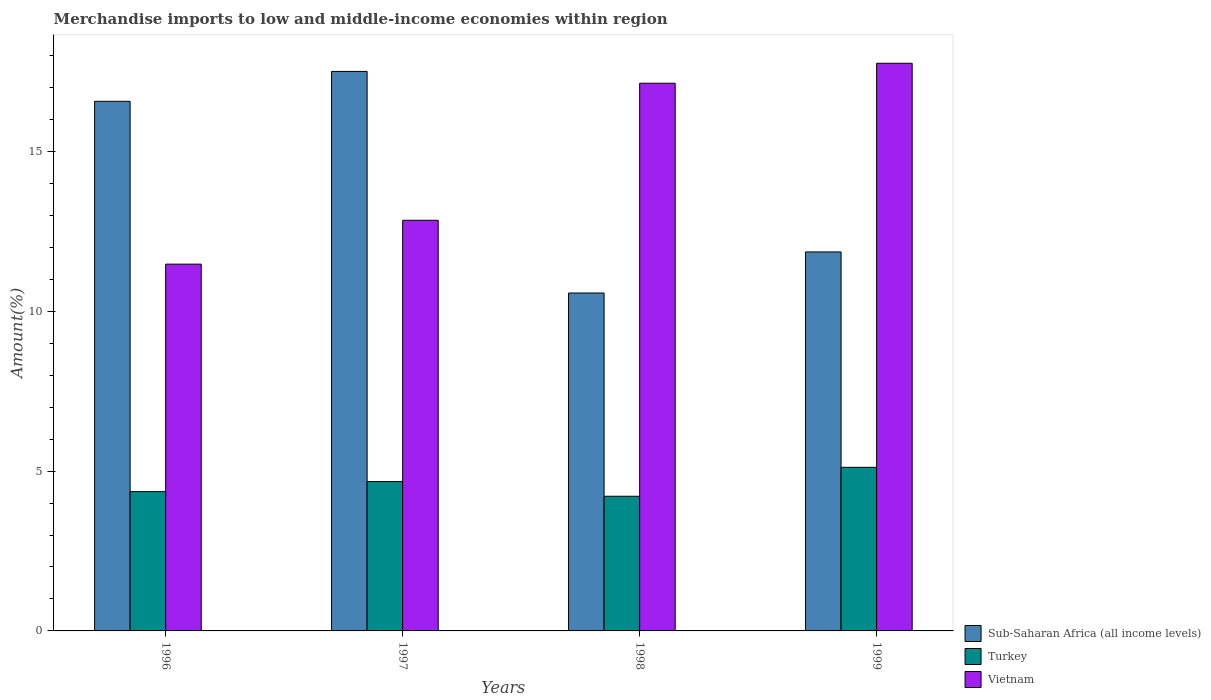How many groups of bars are there?
Keep it short and to the point. 4. How many bars are there on the 2nd tick from the left?
Provide a short and direct response. 3. How many bars are there on the 3rd tick from the right?
Your answer should be compact. 3. In how many cases, is the number of bars for a given year not equal to the number of legend labels?
Keep it short and to the point. 0. What is the percentage of amount earned from merchandise imports in Sub-Saharan Africa (all income levels) in 1999?
Your answer should be very brief. 11.86. Across all years, what is the maximum percentage of amount earned from merchandise imports in Turkey?
Give a very brief answer. 5.12. Across all years, what is the minimum percentage of amount earned from merchandise imports in Sub-Saharan Africa (all income levels)?
Ensure brevity in your answer.  10.57. In which year was the percentage of amount earned from merchandise imports in Sub-Saharan Africa (all income levels) maximum?
Ensure brevity in your answer.  1997. What is the total percentage of amount earned from merchandise imports in Vietnam in the graph?
Give a very brief answer. 59.22. What is the difference between the percentage of amount earned from merchandise imports in Sub-Saharan Africa (all income levels) in 1997 and that in 1999?
Keep it short and to the point. 5.65. What is the difference between the percentage of amount earned from merchandise imports in Turkey in 1998 and the percentage of amount earned from merchandise imports in Sub-Saharan Africa (all income levels) in 1997?
Give a very brief answer. -13.29. What is the average percentage of amount earned from merchandise imports in Turkey per year?
Provide a short and direct response. 4.59. In the year 1996, what is the difference between the percentage of amount earned from merchandise imports in Sub-Saharan Africa (all income levels) and percentage of amount earned from merchandise imports in Turkey?
Keep it short and to the point. 12.21. What is the ratio of the percentage of amount earned from merchandise imports in Turkey in 1998 to that in 1999?
Provide a succinct answer. 0.82. Is the difference between the percentage of amount earned from merchandise imports in Sub-Saharan Africa (all income levels) in 1996 and 1998 greater than the difference between the percentage of amount earned from merchandise imports in Turkey in 1996 and 1998?
Ensure brevity in your answer.  Yes. What is the difference between the highest and the second highest percentage of amount earned from merchandise imports in Sub-Saharan Africa (all income levels)?
Make the answer very short. 0.94. What is the difference between the highest and the lowest percentage of amount earned from merchandise imports in Turkey?
Provide a short and direct response. 0.91. In how many years, is the percentage of amount earned from merchandise imports in Vietnam greater than the average percentage of amount earned from merchandise imports in Vietnam taken over all years?
Offer a terse response. 2. Is the sum of the percentage of amount earned from merchandise imports in Sub-Saharan Africa (all income levels) in 1996 and 1998 greater than the maximum percentage of amount earned from merchandise imports in Vietnam across all years?
Offer a very short reply. Yes. What does the 2nd bar from the left in 1998 represents?
Provide a succinct answer. Turkey. What does the 3rd bar from the right in 1996 represents?
Your response must be concise. Sub-Saharan Africa (all income levels). Are all the bars in the graph horizontal?
Provide a succinct answer. No. How many years are there in the graph?
Offer a terse response. 4. What is the difference between two consecutive major ticks on the Y-axis?
Make the answer very short. 5. Are the values on the major ticks of Y-axis written in scientific E-notation?
Give a very brief answer. No. Does the graph contain grids?
Provide a short and direct response. No. What is the title of the graph?
Your answer should be very brief. Merchandise imports to low and middle-income economies within region. Does "Luxembourg" appear as one of the legend labels in the graph?
Your answer should be very brief. No. What is the label or title of the X-axis?
Offer a terse response. Years. What is the label or title of the Y-axis?
Your answer should be very brief. Amount(%). What is the Amount(%) of Sub-Saharan Africa (all income levels) in 1996?
Offer a very short reply. 16.57. What is the Amount(%) of Turkey in 1996?
Your answer should be very brief. 4.36. What is the Amount(%) of Vietnam in 1996?
Offer a terse response. 11.48. What is the Amount(%) of Sub-Saharan Africa (all income levels) in 1997?
Give a very brief answer. 17.51. What is the Amount(%) of Turkey in 1997?
Keep it short and to the point. 4.67. What is the Amount(%) in Vietnam in 1997?
Ensure brevity in your answer.  12.85. What is the Amount(%) of Sub-Saharan Africa (all income levels) in 1998?
Your answer should be very brief. 10.57. What is the Amount(%) of Turkey in 1998?
Offer a very short reply. 4.21. What is the Amount(%) of Vietnam in 1998?
Your answer should be compact. 17.14. What is the Amount(%) of Sub-Saharan Africa (all income levels) in 1999?
Ensure brevity in your answer.  11.86. What is the Amount(%) of Turkey in 1999?
Keep it short and to the point. 5.12. What is the Amount(%) in Vietnam in 1999?
Offer a terse response. 17.76. Across all years, what is the maximum Amount(%) in Sub-Saharan Africa (all income levels)?
Offer a very short reply. 17.51. Across all years, what is the maximum Amount(%) of Turkey?
Ensure brevity in your answer.  5.12. Across all years, what is the maximum Amount(%) of Vietnam?
Give a very brief answer. 17.76. Across all years, what is the minimum Amount(%) of Sub-Saharan Africa (all income levels)?
Provide a short and direct response. 10.57. Across all years, what is the minimum Amount(%) in Turkey?
Make the answer very short. 4.21. Across all years, what is the minimum Amount(%) in Vietnam?
Your answer should be compact. 11.48. What is the total Amount(%) in Sub-Saharan Africa (all income levels) in the graph?
Keep it short and to the point. 56.51. What is the total Amount(%) in Turkey in the graph?
Provide a short and direct response. 18.36. What is the total Amount(%) of Vietnam in the graph?
Your answer should be very brief. 59.22. What is the difference between the Amount(%) of Sub-Saharan Africa (all income levels) in 1996 and that in 1997?
Your response must be concise. -0.94. What is the difference between the Amount(%) in Turkey in 1996 and that in 1997?
Provide a succinct answer. -0.31. What is the difference between the Amount(%) in Vietnam in 1996 and that in 1997?
Ensure brevity in your answer.  -1.37. What is the difference between the Amount(%) of Sub-Saharan Africa (all income levels) in 1996 and that in 1998?
Provide a succinct answer. 6. What is the difference between the Amount(%) of Turkey in 1996 and that in 1998?
Provide a succinct answer. 0.14. What is the difference between the Amount(%) in Vietnam in 1996 and that in 1998?
Keep it short and to the point. -5.66. What is the difference between the Amount(%) in Sub-Saharan Africa (all income levels) in 1996 and that in 1999?
Keep it short and to the point. 4.71. What is the difference between the Amount(%) in Turkey in 1996 and that in 1999?
Your response must be concise. -0.76. What is the difference between the Amount(%) of Vietnam in 1996 and that in 1999?
Provide a succinct answer. -6.29. What is the difference between the Amount(%) in Sub-Saharan Africa (all income levels) in 1997 and that in 1998?
Your answer should be compact. 6.93. What is the difference between the Amount(%) in Turkey in 1997 and that in 1998?
Give a very brief answer. 0.46. What is the difference between the Amount(%) of Vietnam in 1997 and that in 1998?
Offer a very short reply. -4.29. What is the difference between the Amount(%) in Sub-Saharan Africa (all income levels) in 1997 and that in 1999?
Ensure brevity in your answer.  5.65. What is the difference between the Amount(%) of Turkey in 1997 and that in 1999?
Keep it short and to the point. -0.45. What is the difference between the Amount(%) of Vietnam in 1997 and that in 1999?
Provide a succinct answer. -4.91. What is the difference between the Amount(%) in Sub-Saharan Africa (all income levels) in 1998 and that in 1999?
Your response must be concise. -1.29. What is the difference between the Amount(%) of Turkey in 1998 and that in 1999?
Ensure brevity in your answer.  -0.91. What is the difference between the Amount(%) of Vietnam in 1998 and that in 1999?
Provide a succinct answer. -0.62. What is the difference between the Amount(%) in Sub-Saharan Africa (all income levels) in 1996 and the Amount(%) in Turkey in 1997?
Offer a very short reply. 11.9. What is the difference between the Amount(%) of Sub-Saharan Africa (all income levels) in 1996 and the Amount(%) of Vietnam in 1997?
Provide a short and direct response. 3.72. What is the difference between the Amount(%) of Turkey in 1996 and the Amount(%) of Vietnam in 1997?
Keep it short and to the point. -8.49. What is the difference between the Amount(%) in Sub-Saharan Africa (all income levels) in 1996 and the Amount(%) in Turkey in 1998?
Keep it short and to the point. 12.36. What is the difference between the Amount(%) of Sub-Saharan Africa (all income levels) in 1996 and the Amount(%) of Vietnam in 1998?
Make the answer very short. -0.57. What is the difference between the Amount(%) of Turkey in 1996 and the Amount(%) of Vietnam in 1998?
Offer a very short reply. -12.78. What is the difference between the Amount(%) in Sub-Saharan Africa (all income levels) in 1996 and the Amount(%) in Turkey in 1999?
Give a very brief answer. 11.45. What is the difference between the Amount(%) of Sub-Saharan Africa (all income levels) in 1996 and the Amount(%) of Vietnam in 1999?
Offer a terse response. -1.19. What is the difference between the Amount(%) of Turkey in 1996 and the Amount(%) of Vietnam in 1999?
Keep it short and to the point. -13.4. What is the difference between the Amount(%) in Sub-Saharan Africa (all income levels) in 1997 and the Amount(%) in Turkey in 1998?
Your answer should be very brief. 13.29. What is the difference between the Amount(%) of Sub-Saharan Africa (all income levels) in 1997 and the Amount(%) of Vietnam in 1998?
Make the answer very short. 0.37. What is the difference between the Amount(%) in Turkey in 1997 and the Amount(%) in Vietnam in 1998?
Give a very brief answer. -12.46. What is the difference between the Amount(%) of Sub-Saharan Africa (all income levels) in 1997 and the Amount(%) of Turkey in 1999?
Your response must be concise. 12.39. What is the difference between the Amount(%) in Sub-Saharan Africa (all income levels) in 1997 and the Amount(%) in Vietnam in 1999?
Ensure brevity in your answer.  -0.26. What is the difference between the Amount(%) in Turkey in 1997 and the Amount(%) in Vietnam in 1999?
Ensure brevity in your answer.  -13.09. What is the difference between the Amount(%) in Sub-Saharan Africa (all income levels) in 1998 and the Amount(%) in Turkey in 1999?
Your answer should be compact. 5.45. What is the difference between the Amount(%) of Sub-Saharan Africa (all income levels) in 1998 and the Amount(%) of Vietnam in 1999?
Give a very brief answer. -7.19. What is the difference between the Amount(%) in Turkey in 1998 and the Amount(%) in Vietnam in 1999?
Offer a terse response. -13.55. What is the average Amount(%) of Sub-Saharan Africa (all income levels) per year?
Offer a terse response. 14.13. What is the average Amount(%) of Turkey per year?
Offer a terse response. 4.59. What is the average Amount(%) in Vietnam per year?
Your answer should be very brief. 14.81. In the year 1996, what is the difference between the Amount(%) in Sub-Saharan Africa (all income levels) and Amount(%) in Turkey?
Your response must be concise. 12.21. In the year 1996, what is the difference between the Amount(%) in Sub-Saharan Africa (all income levels) and Amount(%) in Vietnam?
Offer a terse response. 5.09. In the year 1996, what is the difference between the Amount(%) in Turkey and Amount(%) in Vietnam?
Your answer should be compact. -7.12. In the year 1997, what is the difference between the Amount(%) in Sub-Saharan Africa (all income levels) and Amount(%) in Turkey?
Make the answer very short. 12.83. In the year 1997, what is the difference between the Amount(%) of Sub-Saharan Africa (all income levels) and Amount(%) of Vietnam?
Your answer should be compact. 4.66. In the year 1997, what is the difference between the Amount(%) in Turkey and Amount(%) in Vietnam?
Your response must be concise. -8.18. In the year 1998, what is the difference between the Amount(%) in Sub-Saharan Africa (all income levels) and Amount(%) in Turkey?
Give a very brief answer. 6.36. In the year 1998, what is the difference between the Amount(%) of Sub-Saharan Africa (all income levels) and Amount(%) of Vietnam?
Your response must be concise. -6.56. In the year 1998, what is the difference between the Amount(%) of Turkey and Amount(%) of Vietnam?
Offer a terse response. -12.92. In the year 1999, what is the difference between the Amount(%) in Sub-Saharan Africa (all income levels) and Amount(%) in Turkey?
Your answer should be very brief. 6.74. In the year 1999, what is the difference between the Amount(%) in Sub-Saharan Africa (all income levels) and Amount(%) in Vietnam?
Provide a short and direct response. -5.9. In the year 1999, what is the difference between the Amount(%) in Turkey and Amount(%) in Vietnam?
Offer a very short reply. -12.64. What is the ratio of the Amount(%) in Sub-Saharan Africa (all income levels) in 1996 to that in 1997?
Provide a short and direct response. 0.95. What is the ratio of the Amount(%) in Turkey in 1996 to that in 1997?
Offer a very short reply. 0.93. What is the ratio of the Amount(%) of Vietnam in 1996 to that in 1997?
Your answer should be very brief. 0.89. What is the ratio of the Amount(%) of Sub-Saharan Africa (all income levels) in 1996 to that in 1998?
Give a very brief answer. 1.57. What is the ratio of the Amount(%) in Turkey in 1996 to that in 1998?
Your answer should be compact. 1.03. What is the ratio of the Amount(%) of Vietnam in 1996 to that in 1998?
Provide a succinct answer. 0.67. What is the ratio of the Amount(%) of Sub-Saharan Africa (all income levels) in 1996 to that in 1999?
Offer a terse response. 1.4. What is the ratio of the Amount(%) in Turkey in 1996 to that in 1999?
Make the answer very short. 0.85. What is the ratio of the Amount(%) of Vietnam in 1996 to that in 1999?
Make the answer very short. 0.65. What is the ratio of the Amount(%) of Sub-Saharan Africa (all income levels) in 1997 to that in 1998?
Make the answer very short. 1.66. What is the ratio of the Amount(%) in Turkey in 1997 to that in 1998?
Give a very brief answer. 1.11. What is the ratio of the Amount(%) in Vietnam in 1997 to that in 1998?
Your answer should be very brief. 0.75. What is the ratio of the Amount(%) in Sub-Saharan Africa (all income levels) in 1997 to that in 1999?
Your response must be concise. 1.48. What is the ratio of the Amount(%) in Turkey in 1997 to that in 1999?
Ensure brevity in your answer.  0.91. What is the ratio of the Amount(%) of Vietnam in 1997 to that in 1999?
Keep it short and to the point. 0.72. What is the ratio of the Amount(%) of Sub-Saharan Africa (all income levels) in 1998 to that in 1999?
Provide a short and direct response. 0.89. What is the ratio of the Amount(%) in Turkey in 1998 to that in 1999?
Give a very brief answer. 0.82. What is the ratio of the Amount(%) of Vietnam in 1998 to that in 1999?
Make the answer very short. 0.96. What is the difference between the highest and the second highest Amount(%) in Sub-Saharan Africa (all income levels)?
Your answer should be compact. 0.94. What is the difference between the highest and the second highest Amount(%) of Turkey?
Make the answer very short. 0.45. What is the difference between the highest and the second highest Amount(%) in Vietnam?
Your response must be concise. 0.62. What is the difference between the highest and the lowest Amount(%) in Sub-Saharan Africa (all income levels)?
Your answer should be very brief. 6.93. What is the difference between the highest and the lowest Amount(%) of Turkey?
Your answer should be compact. 0.91. What is the difference between the highest and the lowest Amount(%) of Vietnam?
Make the answer very short. 6.29. 